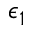<formula> <loc_0><loc_0><loc_500><loc_500>\epsilon _ { 1 }</formula> 